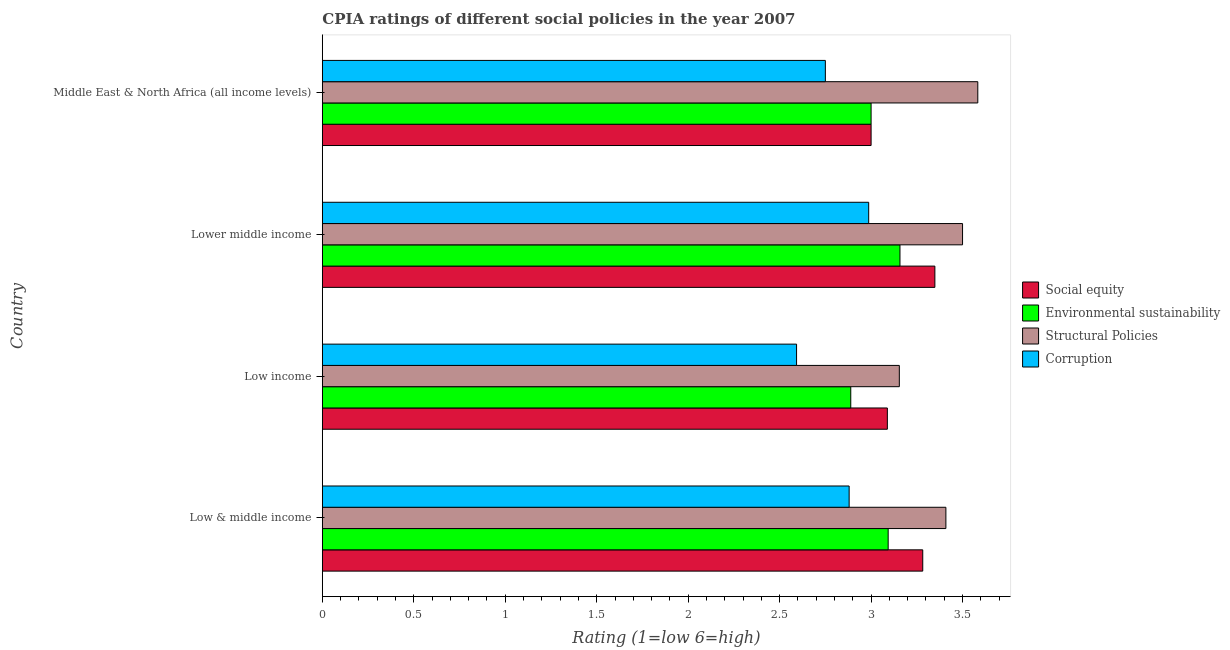How many different coloured bars are there?
Your answer should be compact. 4. How many groups of bars are there?
Keep it short and to the point. 4. What is the cpia rating of structural policies in Middle East & North Africa (all income levels)?
Keep it short and to the point. 3.58. Across all countries, what is the maximum cpia rating of corruption?
Your response must be concise. 2.99. Across all countries, what is the minimum cpia rating of environmental sustainability?
Make the answer very short. 2.89. In which country was the cpia rating of environmental sustainability maximum?
Give a very brief answer. Lower middle income. What is the total cpia rating of corruption in the graph?
Your answer should be very brief. 11.21. What is the difference between the cpia rating of structural policies in Low & middle income and that in Middle East & North Africa (all income levels)?
Make the answer very short. -0.17. What is the difference between the cpia rating of structural policies in Lower middle income and the cpia rating of environmental sustainability in Low income?
Give a very brief answer. 0.61. What is the average cpia rating of corruption per country?
Your response must be concise. 2.8. What is the difference between the cpia rating of environmental sustainability and cpia rating of structural policies in Lower middle income?
Provide a short and direct response. -0.34. What is the ratio of the cpia rating of structural policies in Low & middle income to that in Lower middle income?
Offer a terse response. 0.97. Is the difference between the cpia rating of environmental sustainability in Low income and Lower middle income greater than the difference between the cpia rating of social equity in Low income and Lower middle income?
Make the answer very short. No. What is the difference between the highest and the second highest cpia rating of corruption?
Give a very brief answer. 0.11. What is the difference between the highest and the lowest cpia rating of social equity?
Give a very brief answer. 0.35. Is the sum of the cpia rating of structural policies in Low income and Middle East & North Africa (all income levels) greater than the maximum cpia rating of corruption across all countries?
Give a very brief answer. Yes. Is it the case that in every country, the sum of the cpia rating of environmental sustainability and cpia rating of corruption is greater than the sum of cpia rating of social equity and cpia rating of structural policies?
Provide a succinct answer. No. What does the 1st bar from the top in Low income represents?
Make the answer very short. Corruption. What does the 1st bar from the bottom in Middle East & North Africa (all income levels) represents?
Ensure brevity in your answer.  Social equity. Is it the case that in every country, the sum of the cpia rating of social equity and cpia rating of environmental sustainability is greater than the cpia rating of structural policies?
Your answer should be compact. Yes. How many bars are there?
Offer a very short reply. 16. Does the graph contain grids?
Give a very brief answer. No. What is the title of the graph?
Provide a short and direct response. CPIA ratings of different social policies in the year 2007. Does "Corruption" appear as one of the legend labels in the graph?
Make the answer very short. Yes. What is the Rating (1=low 6=high) of Social equity in Low & middle income?
Offer a very short reply. 3.28. What is the Rating (1=low 6=high) in Environmental sustainability in Low & middle income?
Provide a succinct answer. 3.09. What is the Rating (1=low 6=high) in Structural Policies in Low & middle income?
Offer a very short reply. 3.41. What is the Rating (1=low 6=high) in Corruption in Low & middle income?
Keep it short and to the point. 2.88. What is the Rating (1=low 6=high) of Social equity in Low income?
Give a very brief answer. 3.09. What is the Rating (1=low 6=high) of Environmental sustainability in Low income?
Provide a short and direct response. 2.89. What is the Rating (1=low 6=high) of Structural Policies in Low income?
Ensure brevity in your answer.  3.15. What is the Rating (1=low 6=high) in Corruption in Low income?
Provide a succinct answer. 2.59. What is the Rating (1=low 6=high) of Social equity in Lower middle income?
Your response must be concise. 3.35. What is the Rating (1=low 6=high) in Environmental sustainability in Lower middle income?
Your response must be concise. 3.16. What is the Rating (1=low 6=high) of Structural Policies in Lower middle income?
Make the answer very short. 3.5. What is the Rating (1=low 6=high) of Corruption in Lower middle income?
Your response must be concise. 2.99. What is the Rating (1=low 6=high) in Social equity in Middle East & North Africa (all income levels)?
Your answer should be very brief. 3. What is the Rating (1=low 6=high) in Environmental sustainability in Middle East & North Africa (all income levels)?
Your answer should be very brief. 3. What is the Rating (1=low 6=high) of Structural Policies in Middle East & North Africa (all income levels)?
Provide a succinct answer. 3.58. What is the Rating (1=low 6=high) in Corruption in Middle East & North Africa (all income levels)?
Keep it short and to the point. 2.75. Across all countries, what is the maximum Rating (1=low 6=high) of Social equity?
Make the answer very short. 3.35. Across all countries, what is the maximum Rating (1=low 6=high) in Environmental sustainability?
Give a very brief answer. 3.16. Across all countries, what is the maximum Rating (1=low 6=high) of Structural Policies?
Provide a short and direct response. 3.58. Across all countries, what is the maximum Rating (1=low 6=high) in Corruption?
Offer a terse response. 2.99. Across all countries, what is the minimum Rating (1=low 6=high) in Environmental sustainability?
Your answer should be compact. 2.89. Across all countries, what is the minimum Rating (1=low 6=high) of Structural Policies?
Make the answer very short. 3.15. Across all countries, what is the minimum Rating (1=low 6=high) of Corruption?
Your response must be concise. 2.59. What is the total Rating (1=low 6=high) in Social equity in the graph?
Your response must be concise. 12.72. What is the total Rating (1=low 6=high) of Environmental sustainability in the graph?
Give a very brief answer. 12.14. What is the total Rating (1=low 6=high) of Structural Policies in the graph?
Keep it short and to the point. 13.65. What is the total Rating (1=low 6=high) in Corruption in the graph?
Offer a very short reply. 11.21. What is the difference between the Rating (1=low 6=high) in Social equity in Low & middle income and that in Low income?
Keep it short and to the point. 0.19. What is the difference between the Rating (1=low 6=high) of Environmental sustainability in Low & middle income and that in Low income?
Offer a very short reply. 0.2. What is the difference between the Rating (1=low 6=high) of Structural Policies in Low & middle income and that in Low income?
Provide a short and direct response. 0.25. What is the difference between the Rating (1=low 6=high) of Corruption in Low & middle income and that in Low income?
Keep it short and to the point. 0.29. What is the difference between the Rating (1=low 6=high) in Social equity in Low & middle income and that in Lower middle income?
Your answer should be very brief. -0.07. What is the difference between the Rating (1=low 6=high) in Environmental sustainability in Low & middle income and that in Lower middle income?
Provide a short and direct response. -0.06. What is the difference between the Rating (1=low 6=high) of Structural Policies in Low & middle income and that in Lower middle income?
Your answer should be very brief. -0.09. What is the difference between the Rating (1=low 6=high) of Corruption in Low & middle income and that in Lower middle income?
Make the answer very short. -0.11. What is the difference between the Rating (1=low 6=high) in Social equity in Low & middle income and that in Middle East & North Africa (all income levels)?
Provide a short and direct response. 0.28. What is the difference between the Rating (1=low 6=high) of Environmental sustainability in Low & middle income and that in Middle East & North Africa (all income levels)?
Provide a short and direct response. 0.09. What is the difference between the Rating (1=low 6=high) in Structural Policies in Low & middle income and that in Middle East & North Africa (all income levels)?
Provide a succinct answer. -0.17. What is the difference between the Rating (1=low 6=high) in Corruption in Low & middle income and that in Middle East & North Africa (all income levels)?
Make the answer very short. 0.13. What is the difference between the Rating (1=low 6=high) of Social equity in Low income and that in Lower middle income?
Your answer should be compact. -0.26. What is the difference between the Rating (1=low 6=high) in Environmental sustainability in Low income and that in Lower middle income?
Your answer should be compact. -0.27. What is the difference between the Rating (1=low 6=high) of Structural Policies in Low income and that in Lower middle income?
Make the answer very short. -0.35. What is the difference between the Rating (1=low 6=high) in Corruption in Low income and that in Lower middle income?
Ensure brevity in your answer.  -0.39. What is the difference between the Rating (1=low 6=high) of Social equity in Low income and that in Middle East & North Africa (all income levels)?
Your answer should be compact. 0.09. What is the difference between the Rating (1=low 6=high) of Environmental sustainability in Low income and that in Middle East & North Africa (all income levels)?
Ensure brevity in your answer.  -0.11. What is the difference between the Rating (1=low 6=high) in Structural Policies in Low income and that in Middle East & North Africa (all income levels)?
Provide a succinct answer. -0.43. What is the difference between the Rating (1=low 6=high) of Corruption in Low income and that in Middle East & North Africa (all income levels)?
Make the answer very short. -0.16. What is the difference between the Rating (1=low 6=high) in Social equity in Lower middle income and that in Middle East & North Africa (all income levels)?
Make the answer very short. 0.35. What is the difference between the Rating (1=low 6=high) of Environmental sustainability in Lower middle income and that in Middle East & North Africa (all income levels)?
Keep it short and to the point. 0.16. What is the difference between the Rating (1=low 6=high) of Structural Policies in Lower middle income and that in Middle East & North Africa (all income levels)?
Offer a very short reply. -0.08. What is the difference between the Rating (1=low 6=high) in Corruption in Lower middle income and that in Middle East & North Africa (all income levels)?
Offer a terse response. 0.24. What is the difference between the Rating (1=low 6=high) of Social equity in Low & middle income and the Rating (1=low 6=high) of Environmental sustainability in Low income?
Your answer should be compact. 0.39. What is the difference between the Rating (1=low 6=high) of Social equity in Low & middle income and the Rating (1=low 6=high) of Structural Policies in Low income?
Your response must be concise. 0.13. What is the difference between the Rating (1=low 6=high) of Social equity in Low & middle income and the Rating (1=low 6=high) of Corruption in Low income?
Your answer should be very brief. 0.69. What is the difference between the Rating (1=low 6=high) of Environmental sustainability in Low & middle income and the Rating (1=low 6=high) of Structural Policies in Low income?
Provide a short and direct response. -0.06. What is the difference between the Rating (1=low 6=high) in Environmental sustainability in Low & middle income and the Rating (1=low 6=high) in Corruption in Low income?
Offer a very short reply. 0.5. What is the difference between the Rating (1=low 6=high) in Structural Policies in Low & middle income and the Rating (1=low 6=high) in Corruption in Low income?
Your answer should be compact. 0.82. What is the difference between the Rating (1=low 6=high) in Social equity in Low & middle income and the Rating (1=low 6=high) in Environmental sustainability in Lower middle income?
Your response must be concise. 0.12. What is the difference between the Rating (1=low 6=high) of Social equity in Low & middle income and the Rating (1=low 6=high) of Structural Policies in Lower middle income?
Ensure brevity in your answer.  -0.22. What is the difference between the Rating (1=low 6=high) of Social equity in Low & middle income and the Rating (1=low 6=high) of Corruption in Lower middle income?
Make the answer very short. 0.3. What is the difference between the Rating (1=low 6=high) in Environmental sustainability in Low & middle income and the Rating (1=low 6=high) in Structural Policies in Lower middle income?
Offer a very short reply. -0.41. What is the difference between the Rating (1=low 6=high) of Environmental sustainability in Low & middle income and the Rating (1=low 6=high) of Corruption in Lower middle income?
Your answer should be compact. 0.11. What is the difference between the Rating (1=low 6=high) in Structural Policies in Low & middle income and the Rating (1=low 6=high) in Corruption in Lower middle income?
Make the answer very short. 0.42. What is the difference between the Rating (1=low 6=high) in Social equity in Low & middle income and the Rating (1=low 6=high) in Environmental sustainability in Middle East & North Africa (all income levels)?
Your response must be concise. 0.28. What is the difference between the Rating (1=low 6=high) in Social equity in Low & middle income and the Rating (1=low 6=high) in Structural Policies in Middle East & North Africa (all income levels)?
Offer a very short reply. -0.3. What is the difference between the Rating (1=low 6=high) of Social equity in Low & middle income and the Rating (1=low 6=high) of Corruption in Middle East & North Africa (all income levels)?
Offer a terse response. 0.53. What is the difference between the Rating (1=low 6=high) of Environmental sustainability in Low & middle income and the Rating (1=low 6=high) of Structural Policies in Middle East & North Africa (all income levels)?
Make the answer very short. -0.49. What is the difference between the Rating (1=low 6=high) in Environmental sustainability in Low & middle income and the Rating (1=low 6=high) in Corruption in Middle East & North Africa (all income levels)?
Your response must be concise. 0.34. What is the difference between the Rating (1=low 6=high) of Structural Policies in Low & middle income and the Rating (1=low 6=high) of Corruption in Middle East & North Africa (all income levels)?
Ensure brevity in your answer.  0.66. What is the difference between the Rating (1=low 6=high) in Social equity in Low income and the Rating (1=low 6=high) in Environmental sustainability in Lower middle income?
Provide a succinct answer. -0.07. What is the difference between the Rating (1=low 6=high) of Social equity in Low income and the Rating (1=low 6=high) of Structural Policies in Lower middle income?
Give a very brief answer. -0.41. What is the difference between the Rating (1=low 6=high) in Social equity in Low income and the Rating (1=low 6=high) in Corruption in Lower middle income?
Keep it short and to the point. 0.1. What is the difference between the Rating (1=low 6=high) in Environmental sustainability in Low income and the Rating (1=low 6=high) in Structural Policies in Lower middle income?
Give a very brief answer. -0.61. What is the difference between the Rating (1=low 6=high) in Environmental sustainability in Low income and the Rating (1=low 6=high) in Corruption in Lower middle income?
Your answer should be very brief. -0.1. What is the difference between the Rating (1=low 6=high) in Structural Policies in Low income and the Rating (1=low 6=high) in Corruption in Lower middle income?
Give a very brief answer. 0.17. What is the difference between the Rating (1=low 6=high) of Social equity in Low income and the Rating (1=low 6=high) of Environmental sustainability in Middle East & North Africa (all income levels)?
Provide a short and direct response. 0.09. What is the difference between the Rating (1=low 6=high) of Social equity in Low income and the Rating (1=low 6=high) of Structural Policies in Middle East & North Africa (all income levels)?
Provide a short and direct response. -0.49. What is the difference between the Rating (1=low 6=high) of Social equity in Low income and the Rating (1=low 6=high) of Corruption in Middle East & North Africa (all income levels)?
Make the answer very short. 0.34. What is the difference between the Rating (1=low 6=high) of Environmental sustainability in Low income and the Rating (1=low 6=high) of Structural Policies in Middle East & North Africa (all income levels)?
Your response must be concise. -0.69. What is the difference between the Rating (1=low 6=high) in Environmental sustainability in Low income and the Rating (1=low 6=high) in Corruption in Middle East & North Africa (all income levels)?
Keep it short and to the point. 0.14. What is the difference between the Rating (1=low 6=high) in Structural Policies in Low income and the Rating (1=low 6=high) in Corruption in Middle East & North Africa (all income levels)?
Your response must be concise. 0.4. What is the difference between the Rating (1=low 6=high) of Social equity in Lower middle income and the Rating (1=low 6=high) of Environmental sustainability in Middle East & North Africa (all income levels)?
Provide a short and direct response. 0.35. What is the difference between the Rating (1=low 6=high) in Social equity in Lower middle income and the Rating (1=low 6=high) in Structural Policies in Middle East & North Africa (all income levels)?
Keep it short and to the point. -0.23. What is the difference between the Rating (1=low 6=high) in Social equity in Lower middle income and the Rating (1=low 6=high) in Corruption in Middle East & North Africa (all income levels)?
Keep it short and to the point. 0.6. What is the difference between the Rating (1=low 6=high) in Environmental sustainability in Lower middle income and the Rating (1=low 6=high) in Structural Policies in Middle East & North Africa (all income levels)?
Make the answer very short. -0.43. What is the difference between the Rating (1=low 6=high) in Environmental sustainability in Lower middle income and the Rating (1=low 6=high) in Corruption in Middle East & North Africa (all income levels)?
Keep it short and to the point. 0.41. What is the difference between the Rating (1=low 6=high) of Structural Policies in Lower middle income and the Rating (1=low 6=high) of Corruption in Middle East & North Africa (all income levels)?
Provide a succinct answer. 0.75. What is the average Rating (1=low 6=high) of Social equity per country?
Give a very brief answer. 3.18. What is the average Rating (1=low 6=high) of Environmental sustainability per country?
Your answer should be very brief. 3.04. What is the average Rating (1=low 6=high) of Structural Policies per country?
Offer a very short reply. 3.41. What is the average Rating (1=low 6=high) in Corruption per country?
Your answer should be compact. 2.8. What is the difference between the Rating (1=low 6=high) in Social equity and Rating (1=low 6=high) in Environmental sustainability in Low & middle income?
Provide a short and direct response. 0.19. What is the difference between the Rating (1=low 6=high) in Social equity and Rating (1=low 6=high) in Structural Policies in Low & middle income?
Ensure brevity in your answer.  -0.13. What is the difference between the Rating (1=low 6=high) in Social equity and Rating (1=low 6=high) in Corruption in Low & middle income?
Your answer should be compact. 0.4. What is the difference between the Rating (1=low 6=high) in Environmental sustainability and Rating (1=low 6=high) in Structural Policies in Low & middle income?
Your answer should be compact. -0.32. What is the difference between the Rating (1=low 6=high) of Environmental sustainability and Rating (1=low 6=high) of Corruption in Low & middle income?
Provide a succinct answer. 0.21. What is the difference between the Rating (1=low 6=high) in Structural Policies and Rating (1=low 6=high) in Corruption in Low & middle income?
Provide a short and direct response. 0.53. What is the difference between the Rating (1=low 6=high) of Social equity and Rating (1=low 6=high) of Environmental sustainability in Low income?
Your response must be concise. 0.2. What is the difference between the Rating (1=low 6=high) of Social equity and Rating (1=low 6=high) of Structural Policies in Low income?
Offer a terse response. -0.07. What is the difference between the Rating (1=low 6=high) in Social equity and Rating (1=low 6=high) in Corruption in Low income?
Your response must be concise. 0.5. What is the difference between the Rating (1=low 6=high) of Environmental sustainability and Rating (1=low 6=high) of Structural Policies in Low income?
Your answer should be very brief. -0.27. What is the difference between the Rating (1=low 6=high) in Environmental sustainability and Rating (1=low 6=high) in Corruption in Low income?
Provide a succinct answer. 0.3. What is the difference between the Rating (1=low 6=high) of Structural Policies and Rating (1=low 6=high) of Corruption in Low income?
Your answer should be compact. 0.56. What is the difference between the Rating (1=low 6=high) in Social equity and Rating (1=low 6=high) in Environmental sustainability in Lower middle income?
Give a very brief answer. 0.19. What is the difference between the Rating (1=low 6=high) in Social equity and Rating (1=low 6=high) in Structural Policies in Lower middle income?
Offer a very short reply. -0.15. What is the difference between the Rating (1=low 6=high) of Social equity and Rating (1=low 6=high) of Corruption in Lower middle income?
Offer a terse response. 0.36. What is the difference between the Rating (1=low 6=high) in Environmental sustainability and Rating (1=low 6=high) in Structural Policies in Lower middle income?
Your answer should be very brief. -0.34. What is the difference between the Rating (1=low 6=high) of Environmental sustainability and Rating (1=low 6=high) of Corruption in Lower middle income?
Provide a short and direct response. 0.17. What is the difference between the Rating (1=low 6=high) of Structural Policies and Rating (1=low 6=high) of Corruption in Lower middle income?
Your response must be concise. 0.51. What is the difference between the Rating (1=low 6=high) in Social equity and Rating (1=low 6=high) in Environmental sustainability in Middle East & North Africa (all income levels)?
Make the answer very short. 0. What is the difference between the Rating (1=low 6=high) of Social equity and Rating (1=low 6=high) of Structural Policies in Middle East & North Africa (all income levels)?
Your answer should be compact. -0.58. What is the difference between the Rating (1=low 6=high) in Environmental sustainability and Rating (1=low 6=high) in Structural Policies in Middle East & North Africa (all income levels)?
Ensure brevity in your answer.  -0.58. What is the ratio of the Rating (1=low 6=high) of Social equity in Low & middle income to that in Low income?
Your answer should be very brief. 1.06. What is the ratio of the Rating (1=low 6=high) in Environmental sustainability in Low & middle income to that in Low income?
Offer a very short reply. 1.07. What is the ratio of the Rating (1=low 6=high) in Structural Policies in Low & middle income to that in Low income?
Provide a short and direct response. 1.08. What is the ratio of the Rating (1=low 6=high) in Corruption in Low & middle income to that in Low income?
Offer a terse response. 1.11. What is the ratio of the Rating (1=low 6=high) in Social equity in Low & middle income to that in Lower middle income?
Offer a terse response. 0.98. What is the ratio of the Rating (1=low 6=high) in Environmental sustainability in Low & middle income to that in Lower middle income?
Make the answer very short. 0.98. What is the ratio of the Rating (1=low 6=high) in Corruption in Low & middle income to that in Lower middle income?
Your answer should be compact. 0.96. What is the ratio of the Rating (1=low 6=high) of Social equity in Low & middle income to that in Middle East & North Africa (all income levels)?
Offer a terse response. 1.09. What is the ratio of the Rating (1=low 6=high) of Environmental sustainability in Low & middle income to that in Middle East & North Africa (all income levels)?
Make the answer very short. 1.03. What is the ratio of the Rating (1=low 6=high) in Structural Policies in Low & middle income to that in Middle East & North Africa (all income levels)?
Make the answer very short. 0.95. What is the ratio of the Rating (1=low 6=high) in Corruption in Low & middle income to that in Middle East & North Africa (all income levels)?
Keep it short and to the point. 1.05. What is the ratio of the Rating (1=low 6=high) in Social equity in Low income to that in Lower middle income?
Provide a short and direct response. 0.92. What is the ratio of the Rating (1=low 6=high) of Environmental sustainability in Low income to that in Lower middle income?
Your response must be concise. 0.91. What is the ratio of the Rating (1=low 6=high) of Structural Policies in Low income to that in Lower middle income?
Your answer should be compact. 0.9. What is the ratio of the Rating (1=low 6=high) of Corruption in Low income to that in Lower middle income?
Ensure brevity in your answer.  0.87. What is the ratio of the Rating (1=low 6=high) in Social equity in Low income to that in Middle East & North Africa (all income levels)?
Give a very brief answer. 1.03. What is the ratio of the Rating (1=low 6=high) in Environmental sustainability in Low income to that in Middle East & North Africa (all income levels)?
Your response must be concise. 0.96. What is the ratio of the Rating (1=low 6=high) of Structural Policies in Low income to that in Middle East & North Africa (all income levels)?
Ensure brevity in your answer.  0.88. What is the ratio of the Rating (1=low 6=high) of Corruption in Low income to that in Middle East & North Africa (all income levels)?
Your answer should be very brief. 0.94. What is the ratio of the Rating (1=low 6=high) of Social equity in Lower middle income to that in Middle East & North Africa (all income levels)?
Offer a terse response. 1.12. What is the ratio of the Rating (1=low 6=high) in Environmental sustainability in Lower middle income to that in Middle East & North Africa (all income levels)?
Your answer should be very brief. 1.05. What is the ratio of the Rating (1=low 6=high) in Structural Policies in Lower middle income to that in Middle East & North Africa (all income levels)?
Your answer should be compact. 0.98. What is the ratio of the Rating (1=low 6=high) of Corruption in Lower middle income to that in Middle East & North Africa (all income levels)?
Ensure brevity in your answer.  1.09. What is the difference between the highest and the second highest Rating (1=low 6=high) in Social equity?
Offer a terse response. 0.07. What is the difference between the highest and the second highest Rating (1=low 6=high) of Environmental sustainability?
Keep it short and to the point. 0.06. What is the difference between the highest and the second highest Rating (1=low 6=high) of Structural Policies?
Your response must be concise. 0.08. What is the difference between the highest and the second highest Rating (1=low 6=high) in Corruption?
Provide a succinct answer. 0.11. What is the difference between the highest and the lowest Rating (1=low 6=high) of Social equity?
Your answer should be very brief. 0.35. What is the difference between the highest and the lowest Rating (1=low 6=high) of Environmental sustainability?
Your answer should be very brief. 0.27. What is the difference between the highest and the lowest Rating (1=low 6=high) of Structural Policies?
Ensure brevity in your answer.  0.43. What is the difference between the highest and the lowest Rating (1=low 6=high) in Corruption?
Provide a short and direct response. 0.39. 